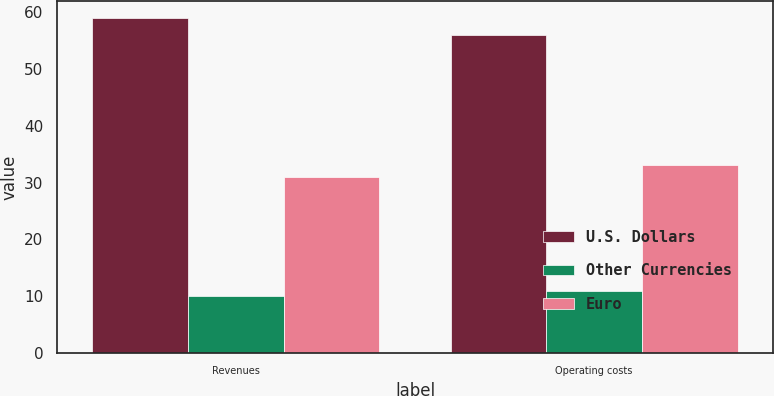<chart> <loc_0><loc_0><loc_500><loc_500><stacked_bar_chart><ecel><fcel>Revenues<fcel>Operating costs<nl><fcel>U.S. Dollars<fcel>59<fcel>56<nl><fcel>Other Currencies<fcel>10<fcel>11<nl><fcel>Euro<fcel>31<fcel>33<nl></chart> 